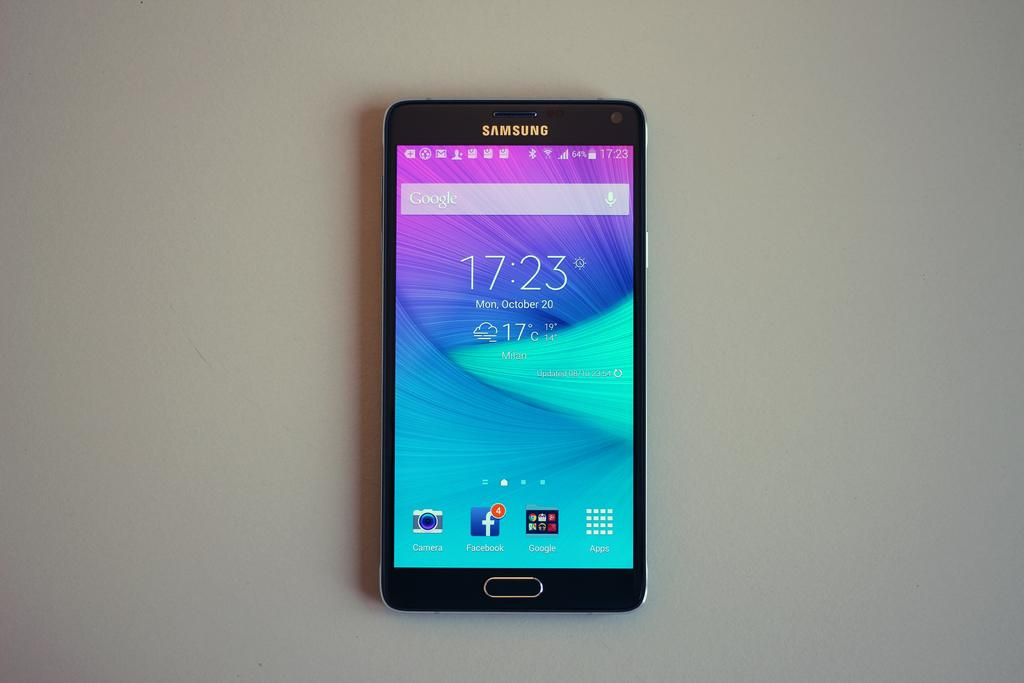<image>
Write a terse but informative summary of the picture. A Samsung phone turned on that says 17:23 